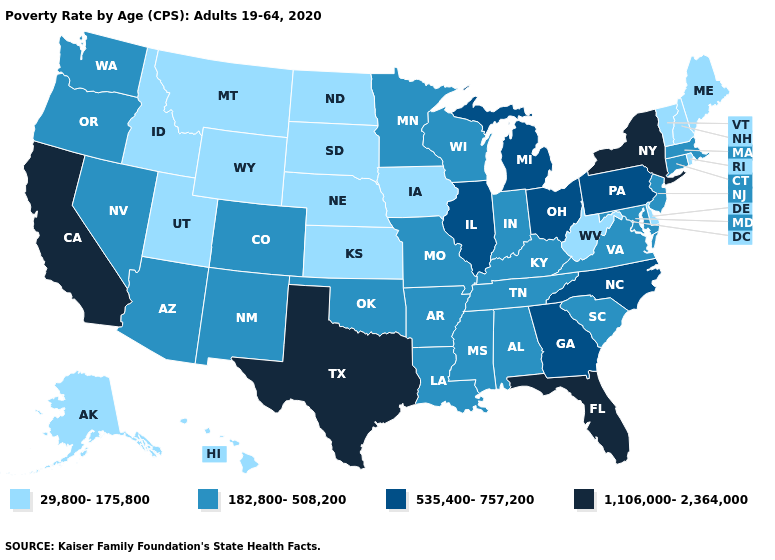Name the states that have a value in the range 182,800-508,200?
Give a very brief answer. Alabama, Arizona, Arkansas, Colorado, Connecticut, Indiana, Kentucky, Louisiana, Maryland, Massachusetts, Minnesota, Mississippi, Missouri, Nevada, New Jersey, New Mexico, Oklahoma, Oregon, South Carolina, Tennessee, Virginia, Washington, Wisconsin. Name the states that have a value in the range 182,800-508,200?
Short answer required. Alabama, Arizona, Arkansas, Colorado, Connecticut, Indiana, Kentucky, Louisiana, Maryland, Massachusetts, Minnesota, Mississippi, Missouri, Nevada, New Jersey, New Mexico, Oklahoma, Oregon, South Carolina, Tennessee, Virginia, Washington, Wisconsin. Which states have the lowest value in the South?
Short answer required. Delaware, West Virginia. What is the value of North Dakota?
Be succinct. 29,800-175,800. What is the highest value in the West ?
Give a very brief answer. 1,106,000-2,364,000. Name the states that have a value in the range 29,800-175,800?
Concise answer only. Alaska, Delaware, Hawaii, Idaho, Iowa, Kansas, Maine, Montana, Nebraska, New Hampshire, North Dakota, Rhode Island, South Dakota, Utah, Vermont, West Virginia, Wyoming. Among the states that border West Virginia , which have the lowest value?
Keep it brief. Kentucky, Maryland, Virginia. Does Texas have the highest value in the South?
Be succinct. Yes. Name the states that have a value in the range 535,400-757,200?
Be succinct. Georgia, Illinois, Michigan, North Carolina, Ohio, Pennsylvania. Does Arizona have a lower value than Kentucky?
Concise answer only. No. Name the states that have a value in the range 29,800-175,800?
Give a very brief answer. Alaska, Delaware, Hawaii, Idaho, Iowa, Kansas, Maine, Montana, Nebraska, New Hampshire, North Dakota, Rhode Island, South Dakota, Utah, Vermont, West Virginia, Wyoming. Which states have the lowest value in the Northeast?
Short answer required. Maine, New Hampshire, Rhode Island, Vermont. What is the highest value in the USA?
Give a very brief answer. 1,106,000-2,364,000. What is the highest value in the South ?
Be succinct. 1,106,000-2,364,000. Does New York have the lowest value in the Northeast?
Answer briefly. No. 